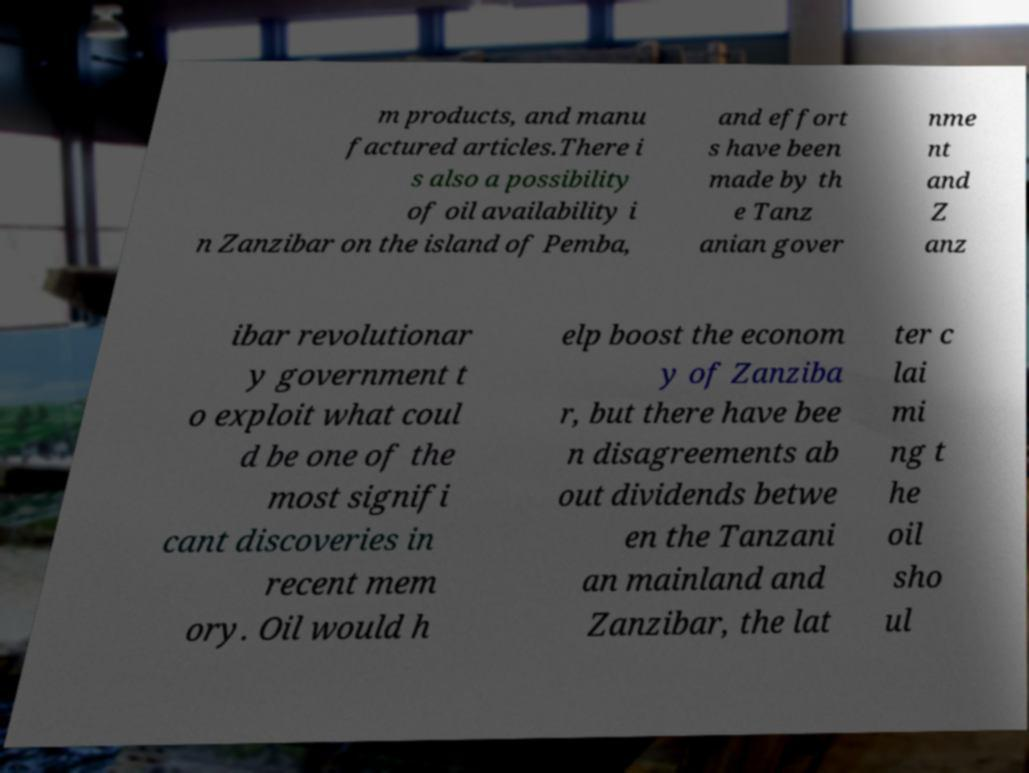Can you accurately transcribe the text from the provided image for me? m products, and manu factured articles.There i s also a possibility of oil availability i n Zanzibar on the island of Pemba, and effort s have been made by th e Tanz anian gover nme nt and Z anz ibar revolutionar y government t o exploit what coul d be one of the most signifi cant discoveries in recent mem ory. Oil would h elp boost the econom y of Zanziba r, but there have bee n disagreements ab out dividends betwe en the Tanzani an mainland and Zanzibar, the lat ter c lai mi ng t he oil sho ul 